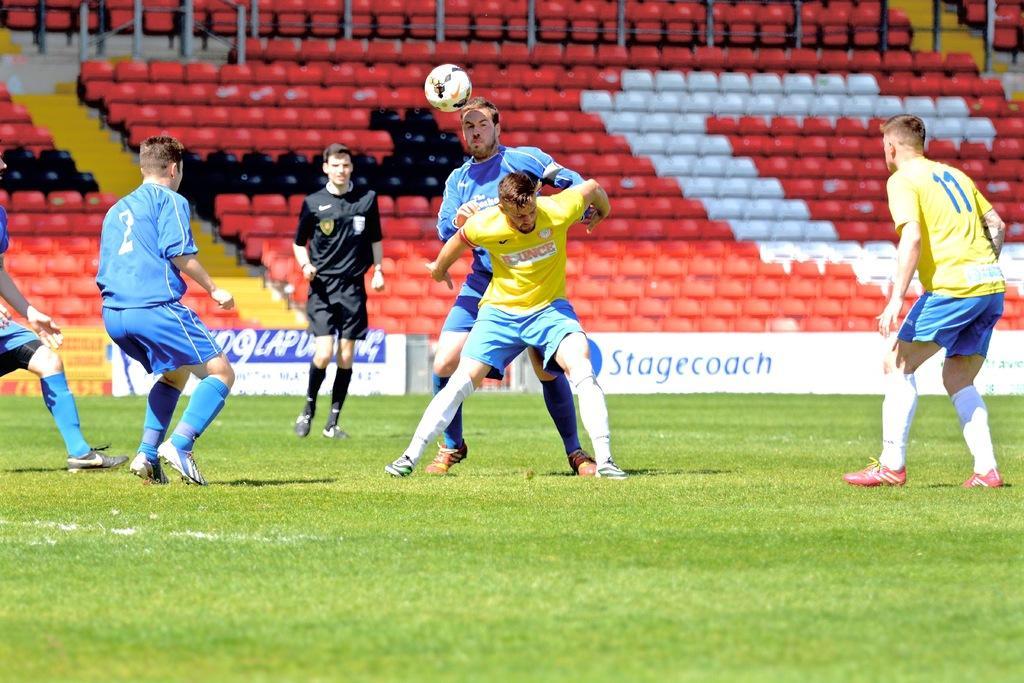Could you give a brief overview of what you see in this image? in the middle of the image two men are standing. Right side of the image a man is standing in yellow dress. Left side of the image two men are standing in blue dress. In the middle of the image a man is standing in black dress. At the bottom of the image there is grass. At the top of the image there is stadium. 